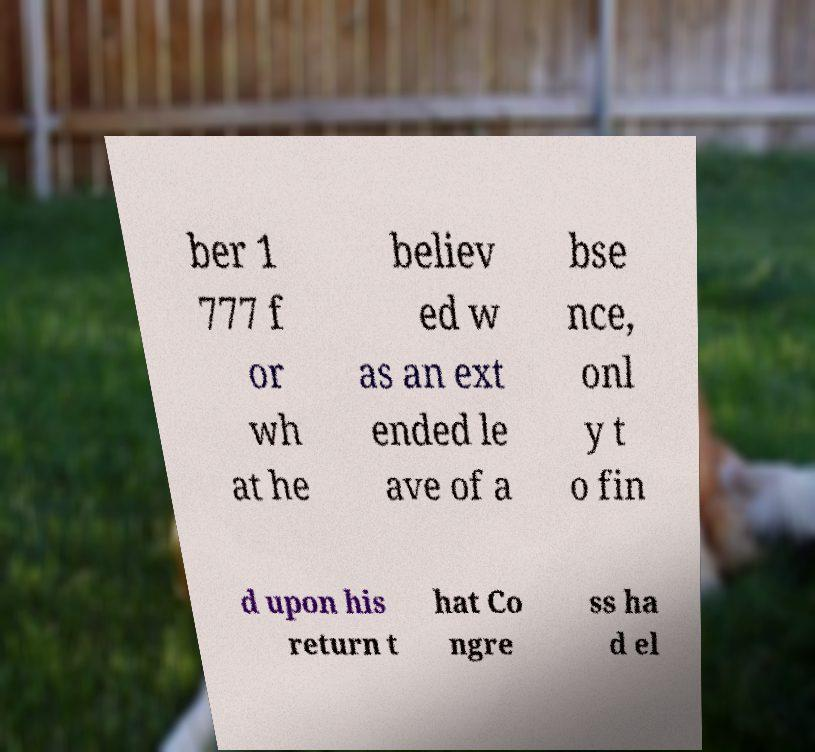Could you assist in decoding the text presented in this image and type it out clearly? ber 1 777 f or wh at he believ ed w as an ext ended le ave of a bse nce, onl y t o fin d upon his return t hat Co ngre ss ha d el 